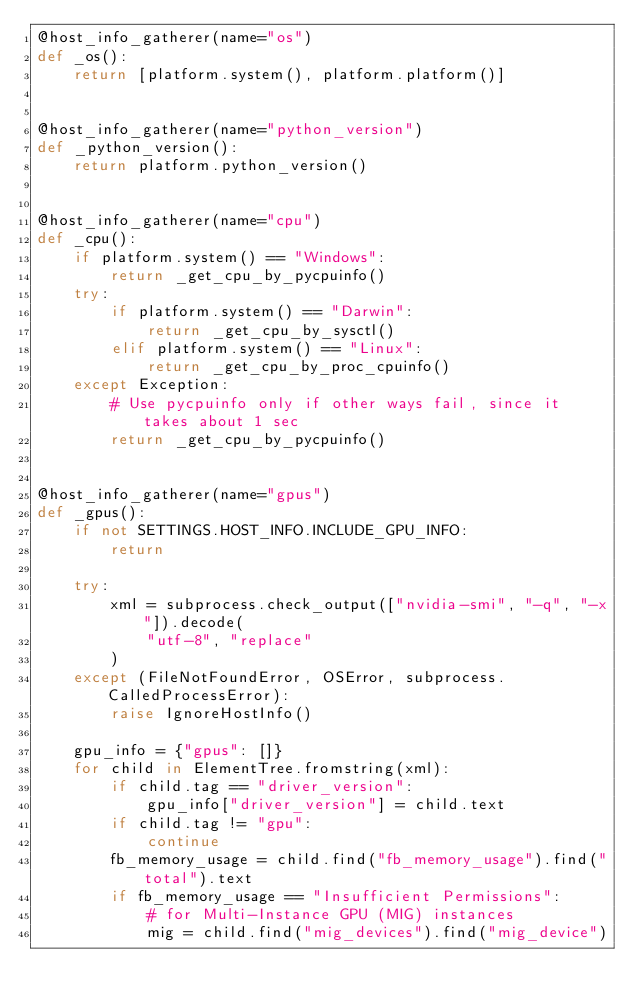<code> <loc_0><loc_0><loc_500><loc_500><_Python_>@host_info_gatherer(name="os")
def _os():
    return [platform.system(), platform.platform()]


@host_info_gatherer(name="python_version")
def _python_version():
    return platform.python_version()


@host_info_gatherer(name="cpu")
def _cpu():
    if platform.system() == "Windows":
        return _get_cpu_by_pycpuinfo()
    try:
        if platform.system() == "Darwin":
            return _get_cpu_by_sysctl()
        elif platform.system() == "Linux":
            return _get_cpu_by_proc_cpuinfo()
    except Exception:
        # Use pycpuinfo only if other ways fail, since it takes about 1 sec
        return _get_cpu_by_pycpuinfo()


@host_info_gatherer(name="gpus")
def _gpus():
    if not SETTINGS.HOST_INFO.INCLUDE_GPU_INFO:
        return

    try:
        xml = subprocess.check_output(["nvidia-smi", "-q", "-x"]).decode(
            "utf-8", "replace"
        )
    except (FileNotFoundError, OSError, subprocess.CalledProcessError):
        raise IgnoreHostInfo()

    gpu_info = {"gpus": []}
    for child in ElementTree.fromstring(xml):
        if child.tag == "driver_version":
            gpu_info["driver_version"] = child.text
        if child.tag != "gpu":
            continue
        fb_memory_usage = child.find("fb_memory_usage").find("total").text
        if fb_memory_usage == "Insufficient Permissions":
            # for Multi-Instance GPU (MIG) instances
            mig = child.find("mig_devices").find("mig_device")</code> 